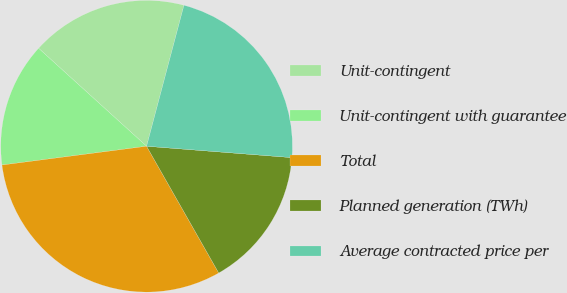Convert chart to OTSL. <chart><loc_0><loc_0><loc_500><loc_500><pie_chart><fcel>Unit-contingent<fcel>Unit-contingent with guarantee<fcel>Total<fcel>Planned generation (TWh)<fcel>Average contracted price per<nl><fcel>17.4%<fcel>13.78%<fcel>31.18%<fcel>15.52%<fcel>22.12%<nl></chart> 